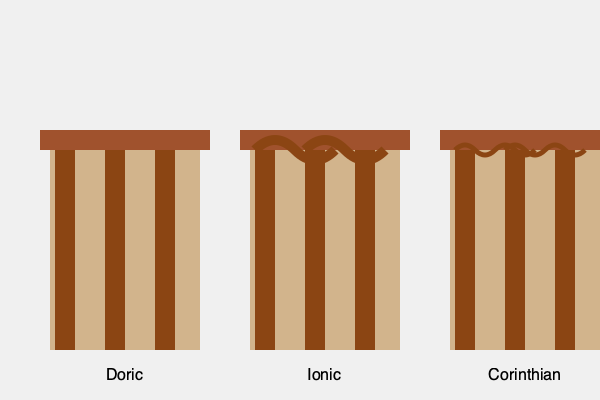Which of the three architectural styles depicted in the image is characterized by simple, unadorned columns and is considered the earliest and most austere of the classical Greek orders? To answer this question, let's analyze the three architectural styles shown in the image:

1. Left column style:
   - Simple, straight columns without decorations
   - No embellishments on the capital (top of the column)
   - Represents the most basic and austere design

2. Middle column style:
   - Columns feature scroll-like decorations (volutes) at the top
   - More ornate than the left style, but still relatively simple

3. Right column style:
   - Highly decorative capitals with leaf-like ornaments
   - The most elaborate and complex of the three styles

Based on these observations:

- The left style is the Doric order, known for its simplicity and lack of adornment.
- The middle style is the Ionic order, recognizable by its scroll decorations.
- The right style is the Corinthian order, characterized by its ornate, leaf-like capital.

The Doric order, represented by the leftmost columns, is indeed the earliest and most austere of the classical Greek orders. It is characterized by simple, unadorned columns with a plain capital and no base.
Answer: Doric 